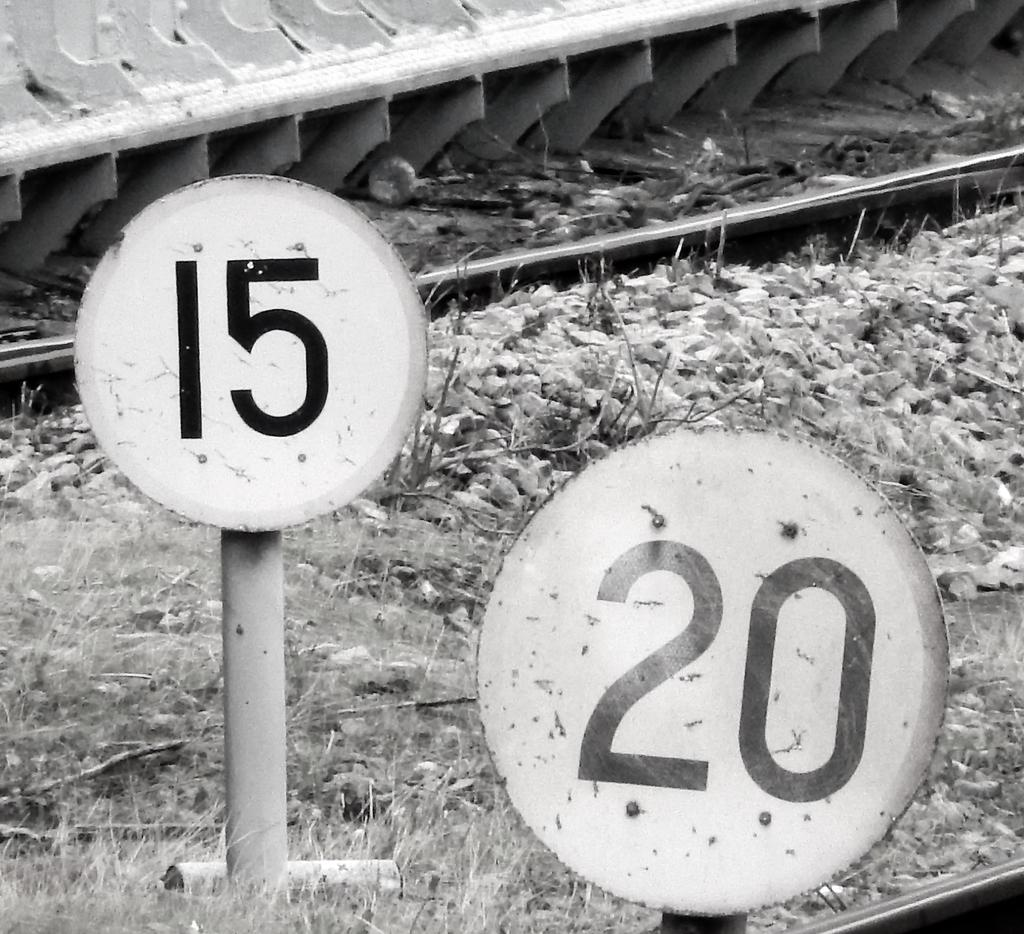<image>
Create a compact narrative representing the image presented. Two signs, one that says 15 and one that says 20. 